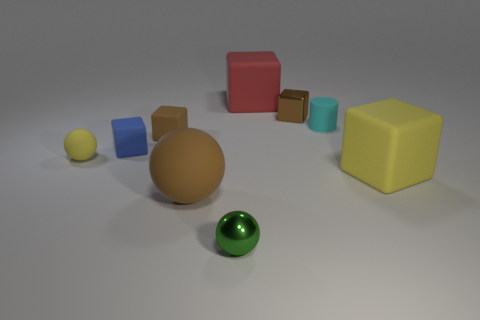Subtract all blue blocks. How many blocks are left? 4 Subtract all green cubes. Subtract all green balls. How many cubes are left? 5 Add 1 red metallic cylinders. How many objects exist? 10 Subtract all balls. How many objects are left? 6 Add 8 tiny brown matte blocks. How many tiny brown matte blocks exist? 9 Subtract 0 cyan balls. How many objects are left? 9 Subtract all green shiny objects. Subtract all big brown objects. How many objects are left? 7 Add 9 green metallic balls. How many green metallic balls are left? 10 